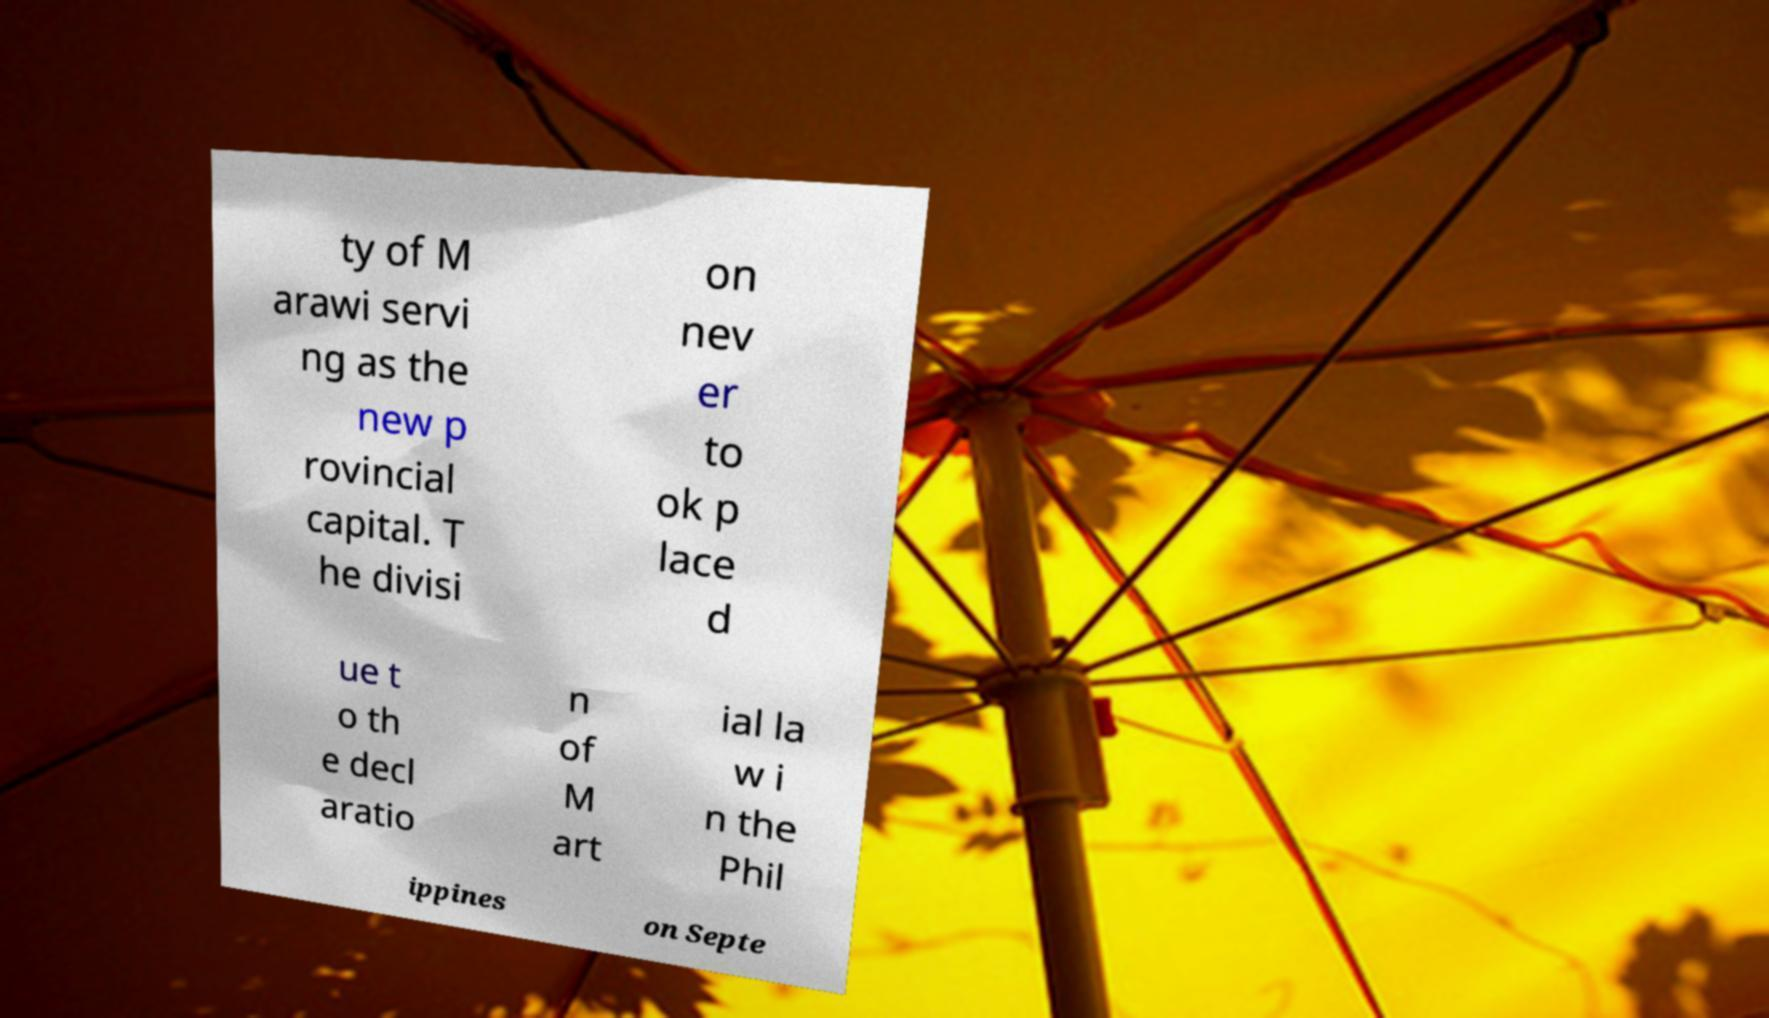For documentation purposes, I need the text within this image transcribed. Could you provide that? ty of M arawi servi ng as the new p rovincial capital. T he divisi on nev er to ok p lace d ue t o th e decl aratio n of M art ial la w i n the Phil ippines on Septe 